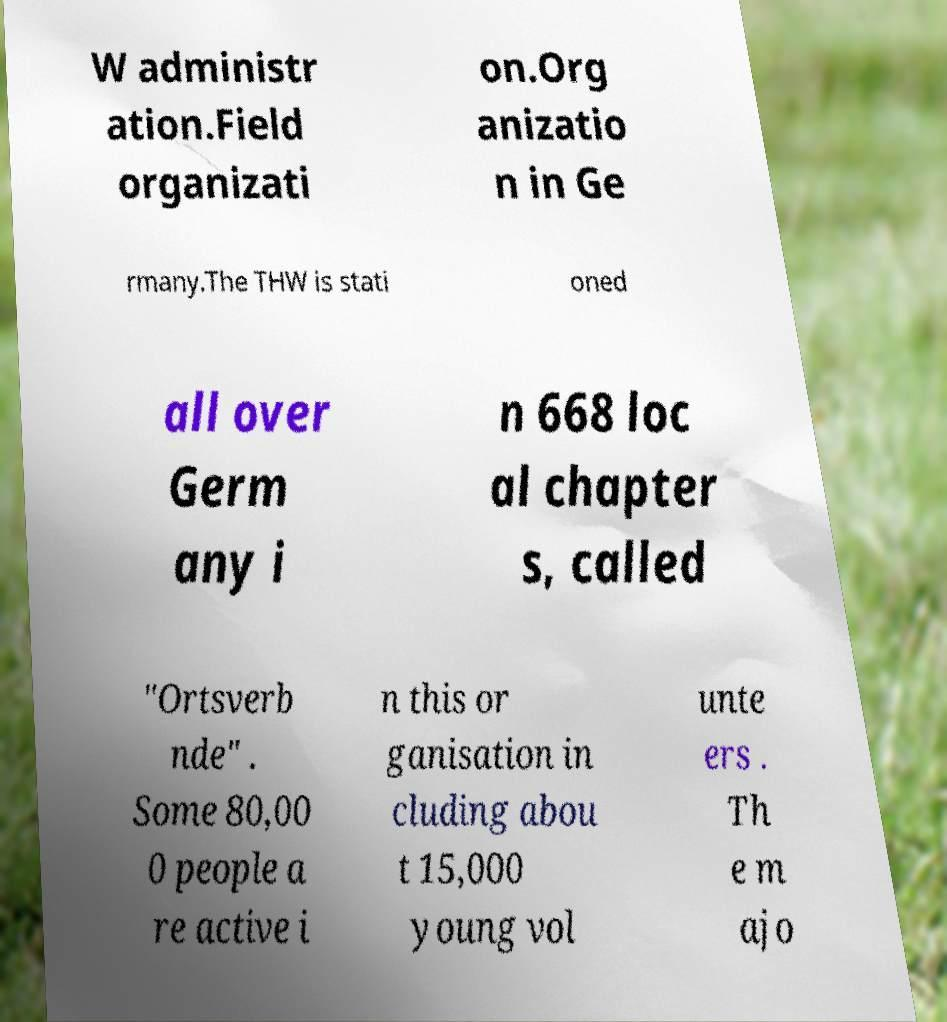Could you extract and type out the text from this image? W administr ation.Field organizati on.Org anizatio n in Ge rmany.The THW is stati oned all over Germ any i n 668 loc al chapter s, called "Ortsverb nde" . Some 80,00 0 people a re active i n this or ganisation in cluding abou t 15,000 young vol unte ers . Th e m ajo 